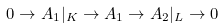Convert formula to latex. <formula><loc_0><loc_0><loc_500><loc_500>0 \rightarrow A _ { 1 } | _ { K } \rightarrow A _ { 1 } \rightarrow A _ { 2 } | _ { L } \rightarrow 0</formula> 